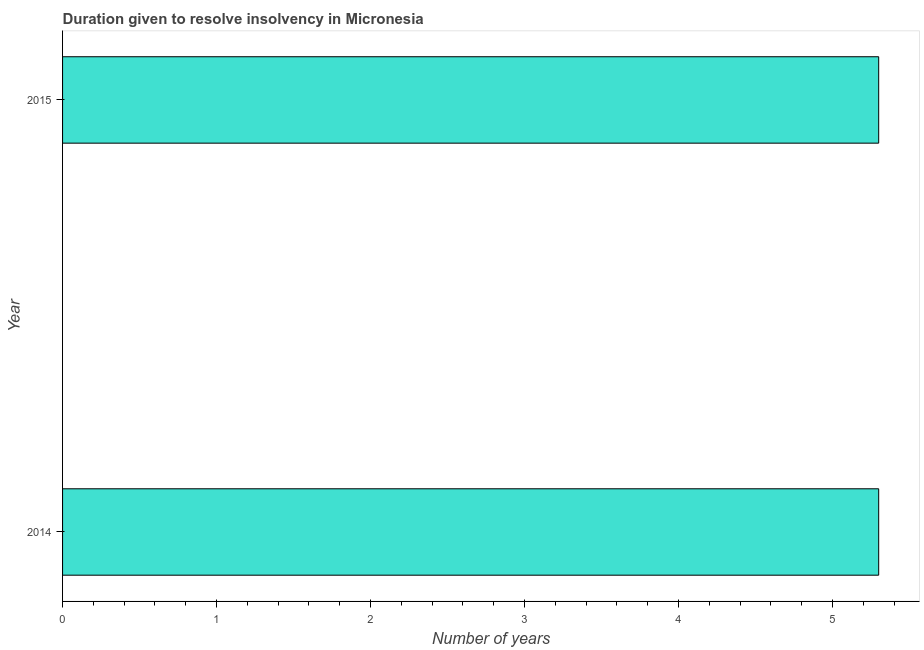Does the graph contain any zero values?
Your answer should be very brief. No. Does the graph contain grids?
Give a very brief answer. No. What is the title of the graph?
Give a very brief answer. Duration given to resolve insolvency in Micronesia. What is the label or title of the X-axis?
Offer a very short reply. Number of years. What is the number of years to resolve insolvency in 2015?
Your answer should be compact. 5.3. Across all years, what is the minimum number of years to resolve insolvency?
Ensure brevity in your answer.  5.3. In which year was the number of years to resolve insolvency maximum?
Keep it short and to the point. 2014. In which year was the number of years to resolve insolvency minimum?
Offer a very short reply. 2014. What is the median number of years to resolve insolvency?
Make the answer very short. 5.3. In how many years, is the number of years to resolve insolvency greater than 2.4 ?
Your response must be concise. 2. Is the number of years to resolve insolvency in 2014 less than that in 2015?
Your answer should be very brief. No. Are all the bars in the graph horizontal?
Make the answer very short. Yes. Are the values on the major ticks of X-axis written in scientific E-notation?
Provide a short and direct response. No. What is the Number of years in 2014?
Your answer should be very brief. 5.3. What is the ratio of the Number of years in 2014 to that in 2015?
Give a very brief answer. 1. 